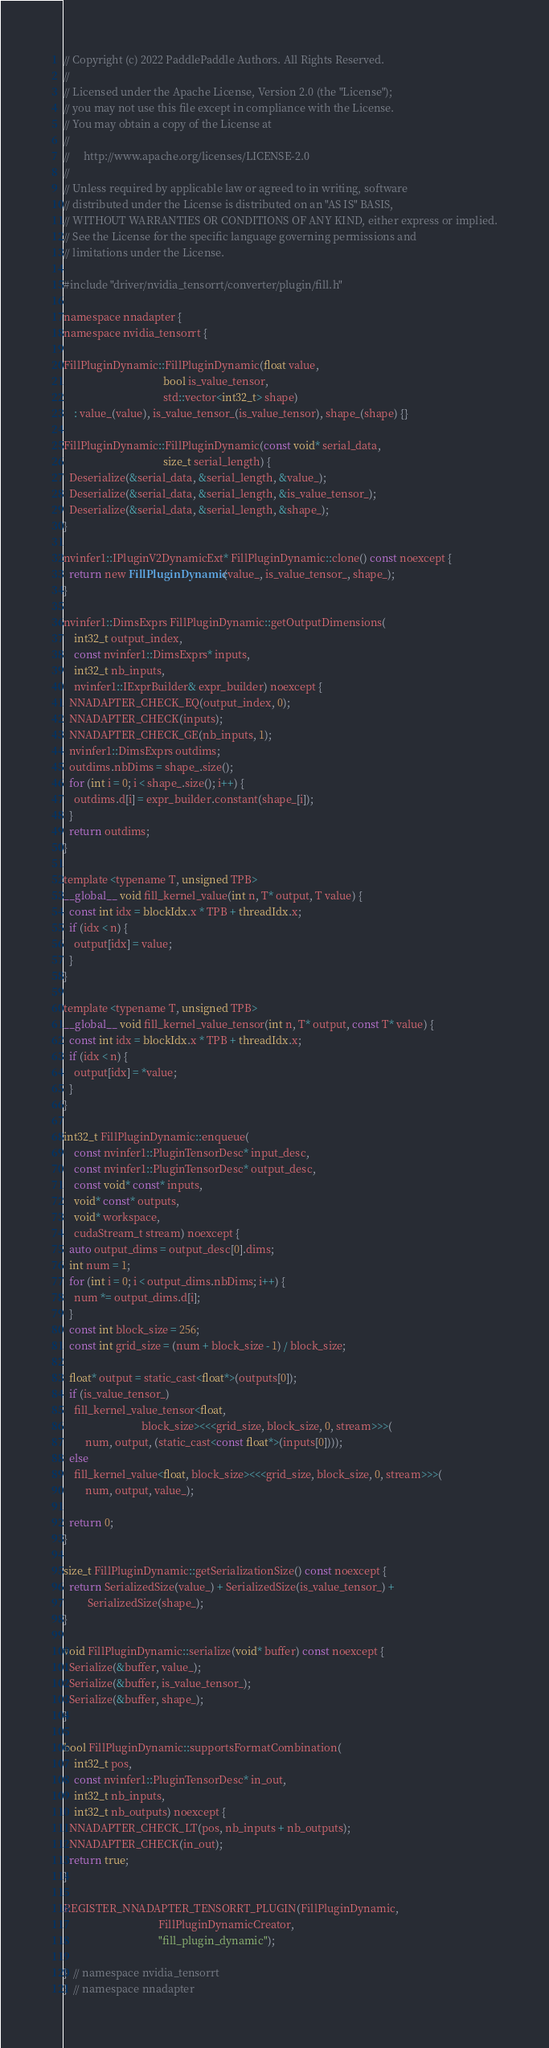<code> <loc_0><loc_0><loc_500><loc_500><_Cuda_>// Copyright (c) 2022 PaddlePaddle Authors. All Rights Reserved.
//
// Licensed under the Apache License, Version 2.0 (the "License");
// you may not use this file except in compliance with the License.
// You may obtain a copy of the License at
//
//     http://www.apache.org/licenses/LICENSE-2.0
//
// Unless required by applicable law or agreed to in writing, software
// distributed under the License is distributed on an "AS IS" BASIS,
// WITHOUT WARRANTIES OR CONDITIONS OF ANY KIND, either express or implied.
// See the License for the specific language governing permissions and
// limitations under the License.

#include "driver/nvidia_tensorrt/converter/plugin/fill.h"

namespace nnadapter {
namespace nvidia_tensorrt {

FillPluginDynamic::FillPluginDynamic(float value,
                                     bool is_value_tensor,
                                     std::vector<int32_t> shape)
    : value_(value), is_value_tensor_(is_value_tensor), shape_(shape) {}

FillPluginDynamic::FillPluginDynamic(const void* serial_data,
                                     size_t serial_length) {
  Deserialize(&serial_data, &serial_length, &value_);
  Deserialize(&serial_data, &serial_length, &is_value_tensor_);
  Deserialize(&serial_data, &serial_length, &shape_);
}

nvinfer1::IPluginV2DynamicExt* FillPluginDynamic::clone() const noexcept {
  return new FillPluginDynamic(value_, is_value_tensor_, shape_);
}

nvinfer1::DimsExprs FillPluginDynamic::getOutputDimensions(
    int32_t output_index,
    const nvinfer1::DimsExprs* inputs,
    int32_t nb_inputs,
    nvinfer1::IExprBuilder& expr_builder) noexcept {
  NNADAPTER_CHECK_EQ(output_index, 0);
  NNADAPTER_CHECK(inputs);
  NNADAPTER_CHECK_GE(nb_inputs, 1);
  nvinfer1::DimsExprs outdims;
  outdims.nbDims = shape_.size();
  for (int i = 0; i < shape_.size(); i++) {
    outdims.d[i] = expr_builder.constant(shape_[i]);
  }
  return outdims;
}

template <typename T, unsigned TPB>
__global__ void fill_kernel_value(int n, T* output, T value) {
  const int idx = blockIdx.x * TPB + threadIdx.x;
  if (idx < n) {
    output[idx] = value;
  }
}

template <typename T, unsigned TPB>
__global__ void fill_kernel_value_tensor(int n, T* output, const T* value) {
  const int idx = blockIdx.x * TPB + threadIdx.x;
  if (idx < n) {
    output[idx] = *value;
  }
}

int32_t FillPluginDynamic::enqueue(
    const nvinfer1::PluginTensorDesc* input_desc,
    const nvinfer1::PluginTensorDesc* output_desc,
    const void* const* inputs,
    void* const* outputs,
    void* workspace,
    cudaStream_t stream) noexcept {
  auto output_dims = output_desc[0].dims;
  int num = 1;
  for (int i = 0; i < output_dims.nbDims; i++) {
    num *= output_dims.d[i];
  }
  const int block_size = 256;
  const int grid_size = (num + block_size - 1) / block_size;

  float* output = static_cast<float*>(outputs[0]);
  if (is_value_tensor_)
    fill_kernel_value_tensor<float,
                             block_size><<<grid_size, block_size, 0, stream>>>(
        num, output, (static_cast<const float*>(inputs[0])));
  else
    fill_kernel_value<float, block_size><<<grid_size, block_size, 0, stream>>>(
        num, output, value_);

  return 0;
}

size_t FillPluginDynamic::getSerializationSize() const noexcept {
  return SerializedSize(value_) + SerializedSize(is_value_tensor_) +
         SerializedSize(shape_);
}

void FillPluginDynamic::serialize(void* buffer) const noexcept {
  Serialize(&buffer, value_);
  Serialize(&buffer, is_value_tensor_);
  Serialize(&buffer, shape_);
}

bool FillPluginDynamic::supportsFormatCombination(
    int32_t pos,
    const nvinfer1::PluginTensorDesc* in_out,
    int32_t nb_inputs,
    int32_t nb_outputs) noexcept {
  NNADAPTER_CHECK_LT(pos, nb_inputs + nb_outputs);
  NNADAPTER_CHECK(in_out);
  return true;
}

REGISTER_NNADAPTER_TENSORRT_PLUGIN(FillPluginDynamic,
                                   FillPluginDynamicCreator,
                                   "fill_plugin_dynamic");

}  // namespace nvidia_tensorrt
}  // namespace nnadapter
</code> 